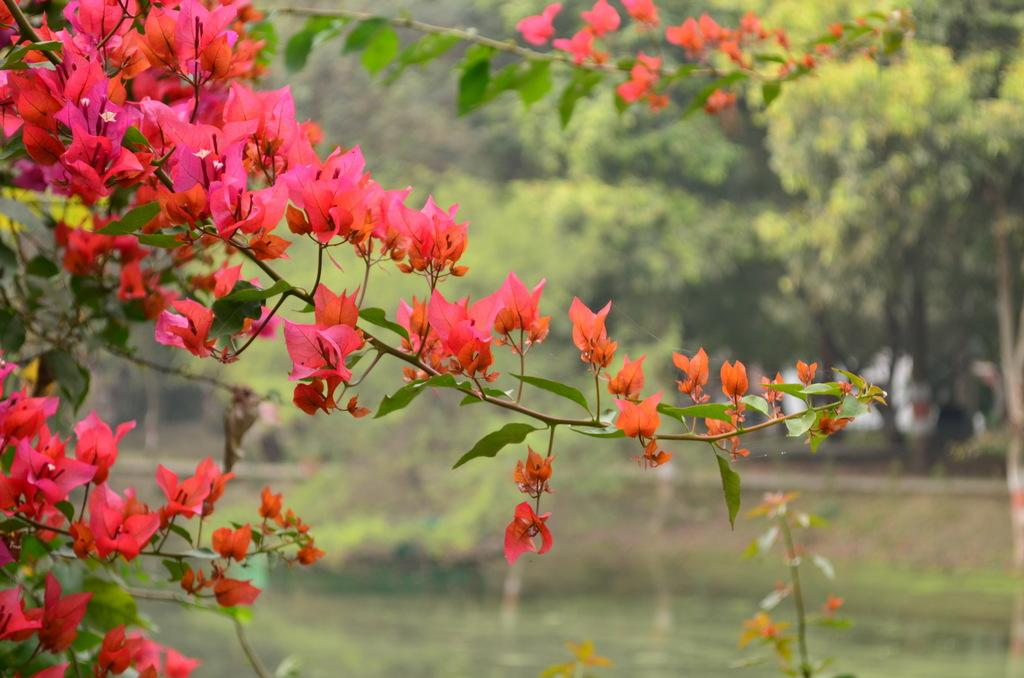What types of vegetation can be seen in the foreground of the image? There are flowers and plants in the foreground of the image. What can be seen in the background of the image? There are trees in the background of the image. What type of drain is visible in the image? There is no drain present in the image. Is there anyone reading a book in the image? There is no indication of anyone reading a book in the image. 